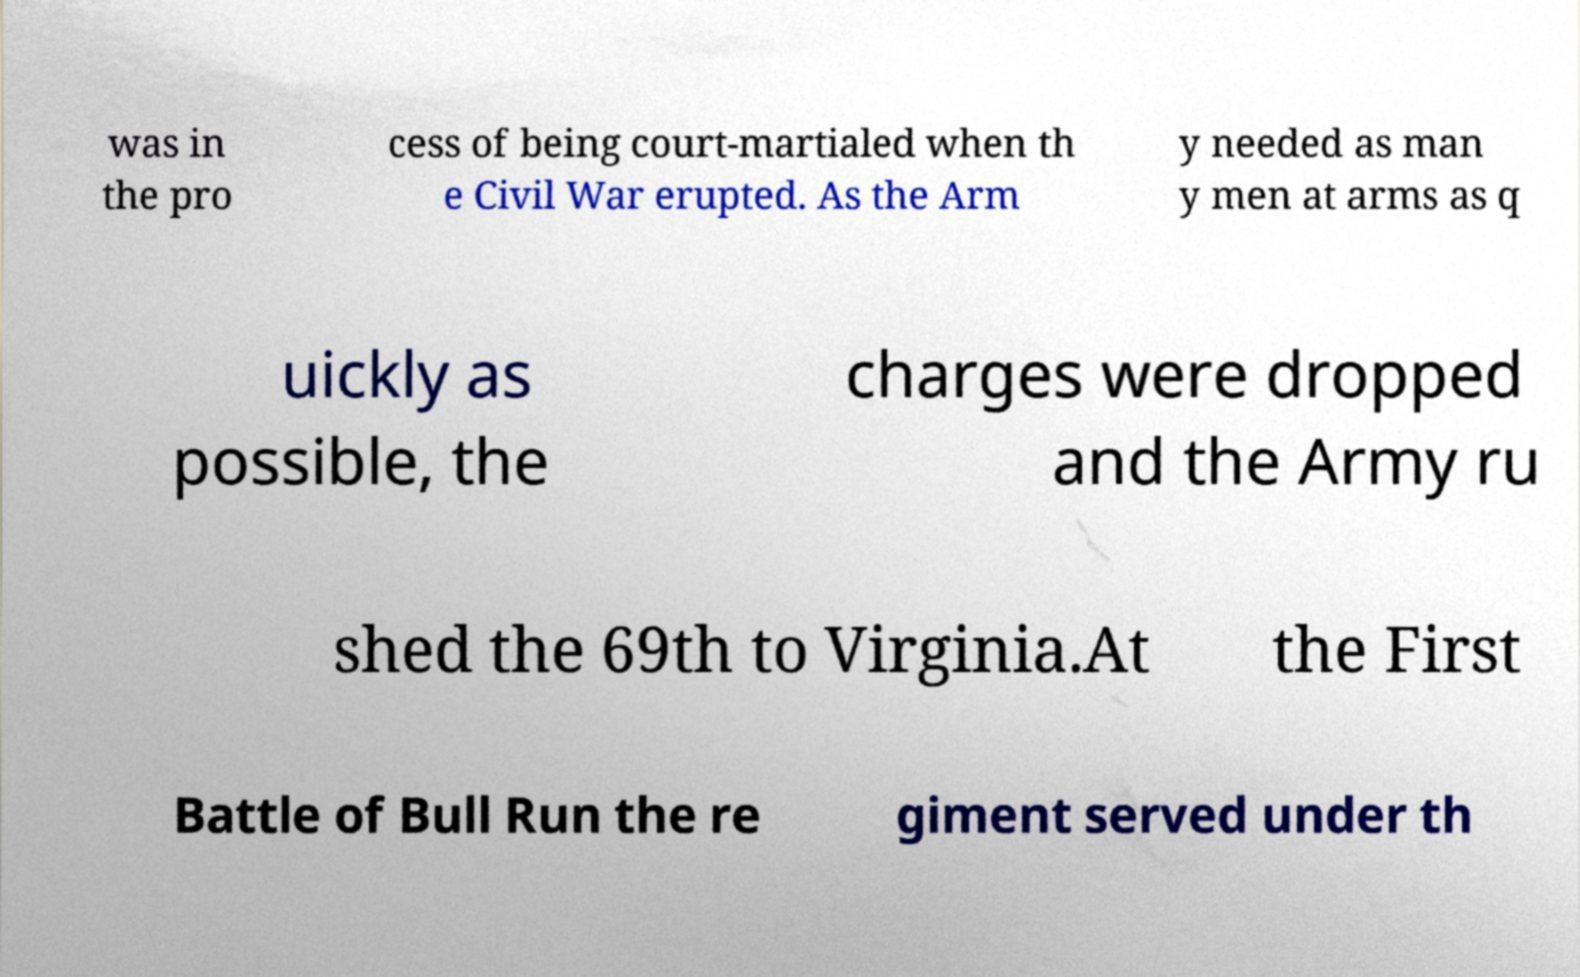Please read and relay the text visible in this image. What does it say? was in the pro cess of being court-martialed when th e Civil War erupted. As the Arm y needed as man y men at arms as q uickly as possible, the charges were dropped and the Army ru shed the 69th to Virginia.At the First Battle of Bull Run the re giment served under th 